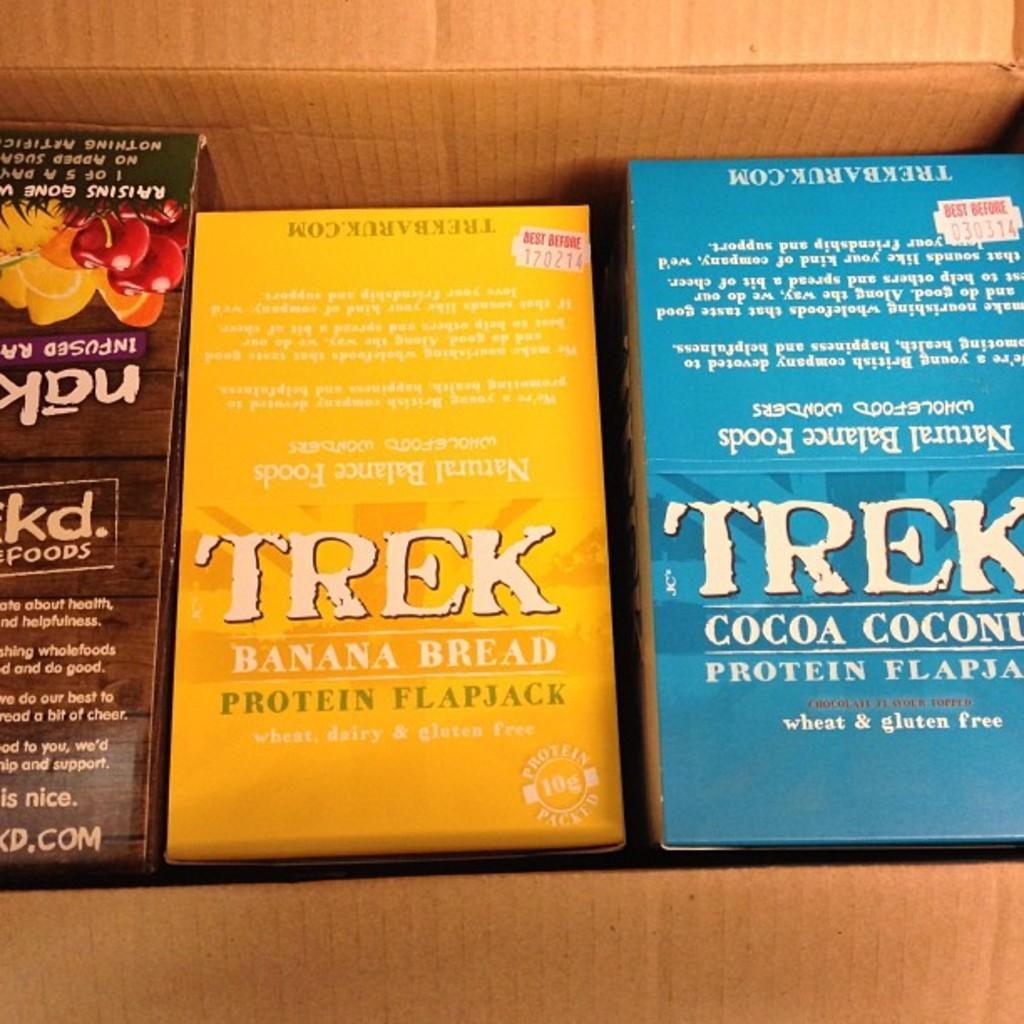Provide a one-sentence caption for the provided image. A cardboard box contains 3 products including TREK Banana Bread and Cocoa Coconut flavored Protein flapjacks. 